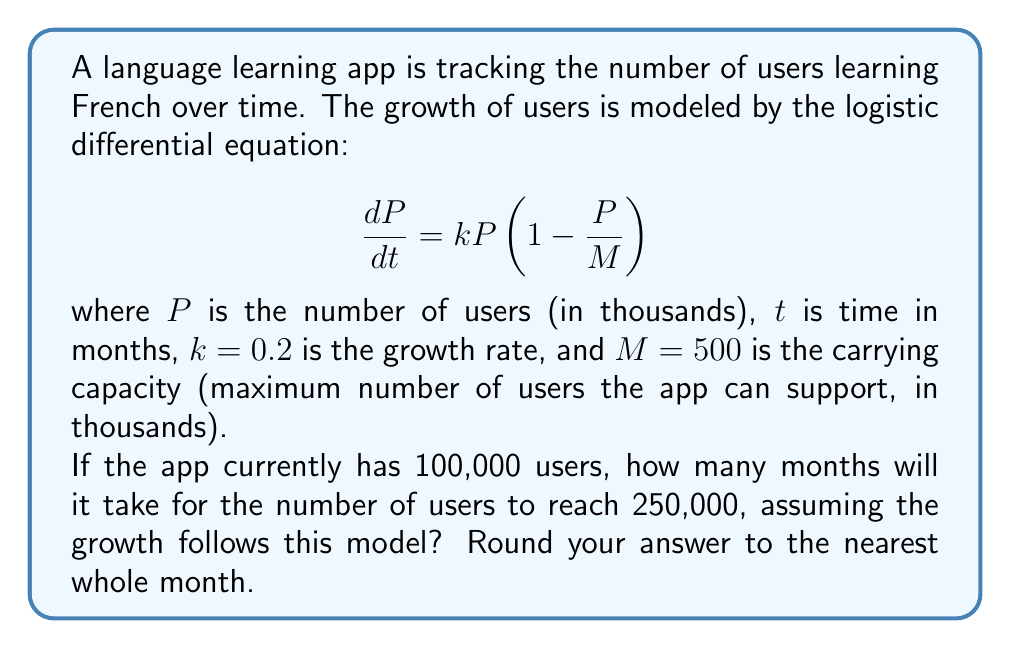Help me with this question. To solve this problem, we'll use the logistic growth model and its solution. The steps are as follows:

1) The general solution to the logistic differential equation is:

   $$P(t) = \frac{M}{1 + Ce^{-kt}}$$

   where $C$ is a constant determined by the initial conditions.

2) We're given that $M = 500$ (in thousands), $k = 0.2$, and $P(0) = 100$ (in thousands).

3) To find $C$, we use the initial condition $P(0) = 100$:

   $$100 = \frac{500}{1 + C}$$

   Solving for $C$:
   $$C = 4$$

4) Now our specific solution is:

   $$P(t) = \frac{500}{1 + 4e^{-0.2t}}$$

5) We want to find $t$ when $P(t) = 250$ (in thousands):

   $$250 = \frac{500}{1 + 4e^{-0.2t}}$$

6) Solving for $t$:

   $$1 + 4e^{-0.2t} = 2$$
   $$4e^{-0.2t} = 1$$
   $$e^{-0.2t} = \frac{1}{4}$$
   $$-0.2t = \ln(\frac{1}{4}) = -\ln(4)$$
   $$t = \frac{\ln(4)}{0.2} \approx 6.93$$

7) Rounding to the nearest whole month, we get 7 months.
Answer: It will take approximately 7 months for the number of users to reach 250,000. 